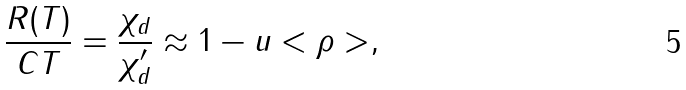<formula> <loc_0><loc_0><loc_500><loc_500>\frac { R ( T ) } { C T } = \frac { \chi _ { d } } { \chi _ { d } ^ { \prime } } \approx 1 - u < \rho > ,</formula> 